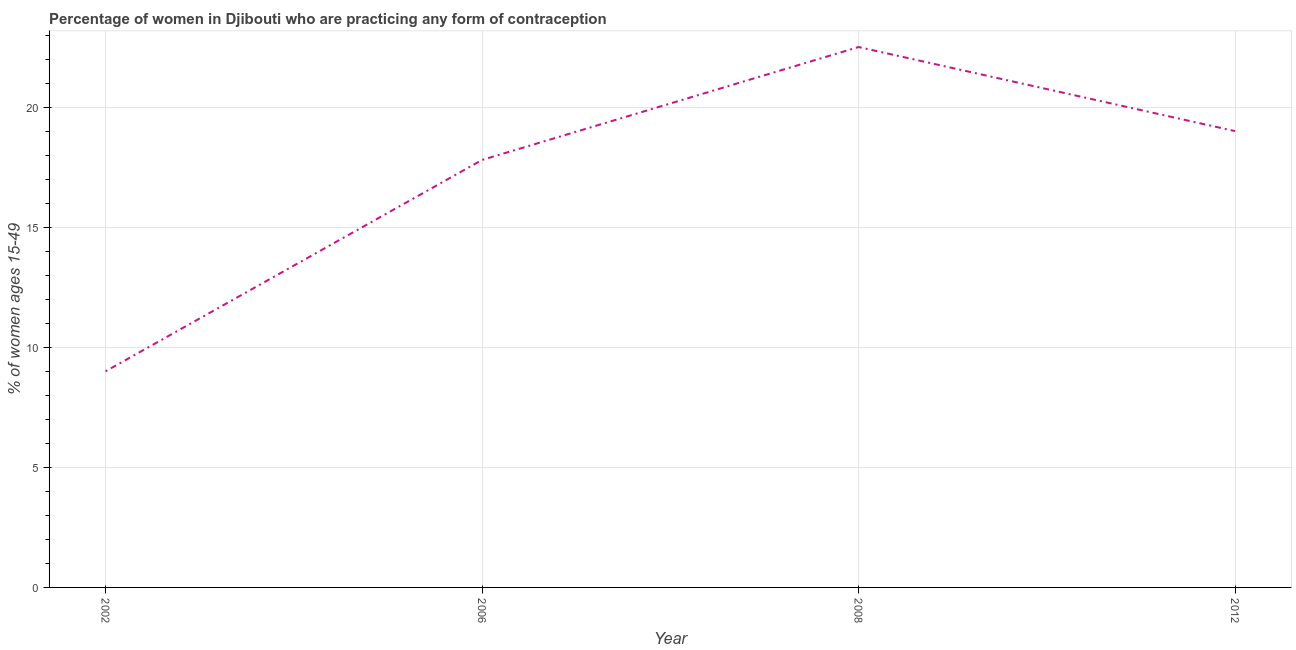What is the contraceptive prevalence in 2006?
Offer a very short reply. 17.8. Across all years, what is the maximum contraceptive prevalence?
Ensure brevity in your answer.  22.5. Across all years, what is the minimum contraceptive prevalence?
Provide a short and direct response. 9. In which year was the contraceptive prevalence minimum?
Offer a very short reply. 2002. What is the sum of the contraceptive prevalence?
Give a very brief answer. 68.3. What is the difference between the contraceptive prevalence in 2008 and 2012?
Provide a short and direct response. 3.5. What is the average contraceptive prevalence per year?
Your answer should be compact. 17.07. What is the median contraceptive prevalence?
Offer a very short reply. 18.4. In how many years, is the contraceptive prevalence greater than 1 %?
Keep it short and to the point. 4. Do a majority of the years between 2006 and 2012 (inclusive) have contraceptive prevalence greater than 17 %?
Give a very brief answer. Yes. What is the ratio of the contraceptive prevalence in 2006 to that in 2012?
Offer a terse response. 0.94. Is the difference between the contraceptive prevalence in 2008 and 2012 greater than the difference between any two years?
Your answer should be compact. No. In how many years, is the contraceptive prevalence greater than the average contraceptive prevalence taken over all years?
Your answer should be compact. 3. What is the title of the graph?
Your answer should be very brief. Percentage of women in Djibouti who are practicing any form of contraception. What is the label or title of the X-axis?
Offer a terse response. Year. What is the label or title of the Y-axis?
Keep it short and to the point. % of women ages 15-49. What is the % of women ages 15-49 of 2008?
Provide a succinct answer. 22.5. What is the % of women ages 15-49 of 2012?
Your response must be concise. 19. What is the difference between the % of women ages 15-49 in 2002 and 2012?
Provide a short and direct response. -10. What is the difference between the % of women ages 15-49 in 2006 and 2012?
Keep it short and to the point. -1.2. What is the ratio of the % of women ages 15-49 in 2002 to that in 2006?
Provide a short and direct response. 0.51. What is the ratio of the % of women ages 15-49 in 2002 to that in 2008?
Your answer should be very brief. 0.4. What is the ratio of the % of women ages 15-49 in 2002 to that in 2012?
Ensure brevity in your answer.  0.47. What is the ratio of the % of women ages 15-49 in 2006 to that in 2008?
Your answer should be compact. 0.79. What is the ratio of the % of women ages 15-49 in 2006 to that in 2012?
Keep it short and to the point. 0.94. What is the ratio of the % of women ages 15-49 in 2008 to that in 2012?
Your answer should be very brief. 1.18. 